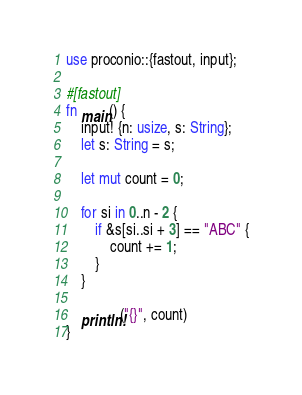<code> <loc_0><loc_0><loc_500><loc_500><_Rust_>use proconio::{fastout, input};

#[fastout]
fn main() {
    input! {n: usize, s: String};
    let s: String = s;

    let mut count = 0;

    for si in 0..n - 2 {
        if &s[si..si + 3] == "ABC" {
            count += 1;
        }
    }

    println!("{}", count)
}
</code> 